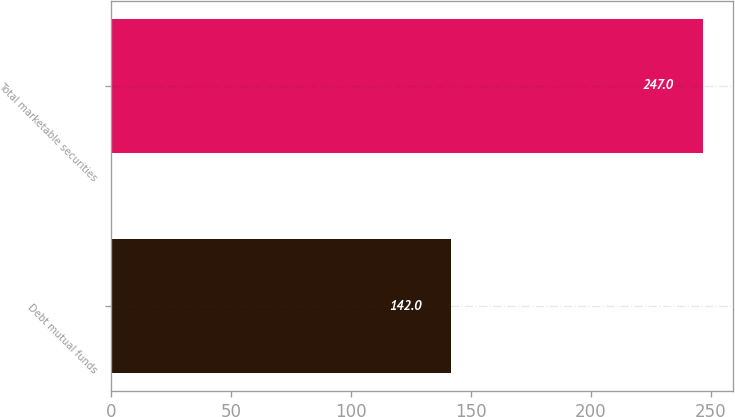<chart> <loc_0><loc_0><loc_500><loc_500><bar_chart><fcel>Debt mutual funds<fcel>Total marketable securities<nl><fcel>142<fcel>247<nl></chart> 